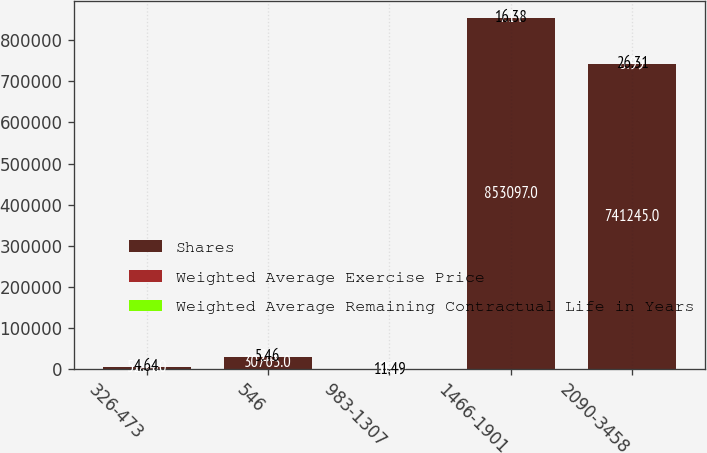Convert chart to OTSL. <chart><loc_0><loc_0><loc_500><loc_500><stacked_bar_chart><ecel><fcel>326-473<fcel>546<fcel>983-1307<fcel>1466-1901<fcel>2090-3458<nl><fcel>Shares<fcel>5244<fcel>30763<fcel>10.24<fcel>853097<fcel>741245<nl><fcel>Weighted Average Exercise Price<fcel>0.95<fcel>2<fcel>5.98<fcel>7.14<fcel>8.99<nl><fcel>Weighted Average Remaining Contractual Life in Years<fcel>4.64<fcel>5.46<fcel>11.49<fcel>16.38<fcel>26.31<nl></chart> 